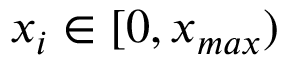<formula> <loc_0><loc_0><loc_500><loc_500>x _ { i } \in [ 0 , x _ { \max } )</formula> 